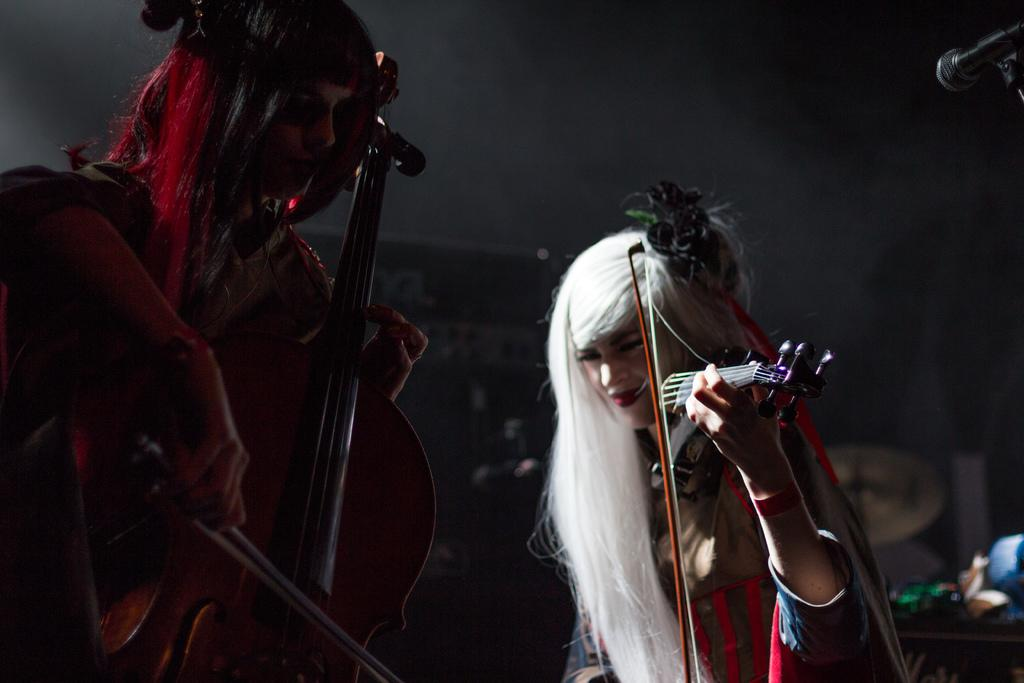How many people are in the image? There are two persons in the image. What are the persons doing in the image? Both persons are playing violins. What other musical instruments can be seen in the image? There are drums visible in the image. Can you describe any other objects in the image? There are other objects in the image, but their specific details are not mentioned in the provided facts. Where is the microphone located in the image? There is a microphone in the top right corner of the image. What color is the water in the image? There is no water present in the image. How does the person on the left cry while playing the violin? There is no indication in the image that the person on the left is crying; they are focused on playing the violin. 